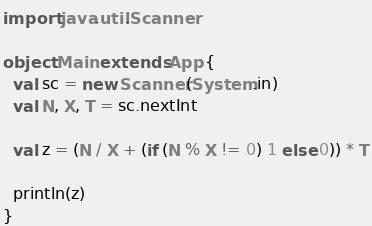Convert code to text. <code><loc_0><loc_0><loc_500><loc_500><_Scala_>import java.util.Scanner

object Main extends App {
  val sc = new Scanner(System.in)
  val N, X, T = sc.nextInt

  val z = (N / X + (if (N % X != 0) 1 else 0)) * T

  println(z)
}
</code> 